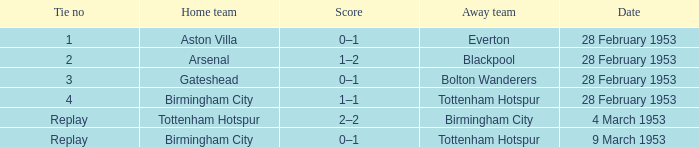Which score has a stalemate no of 1? 0–1. 